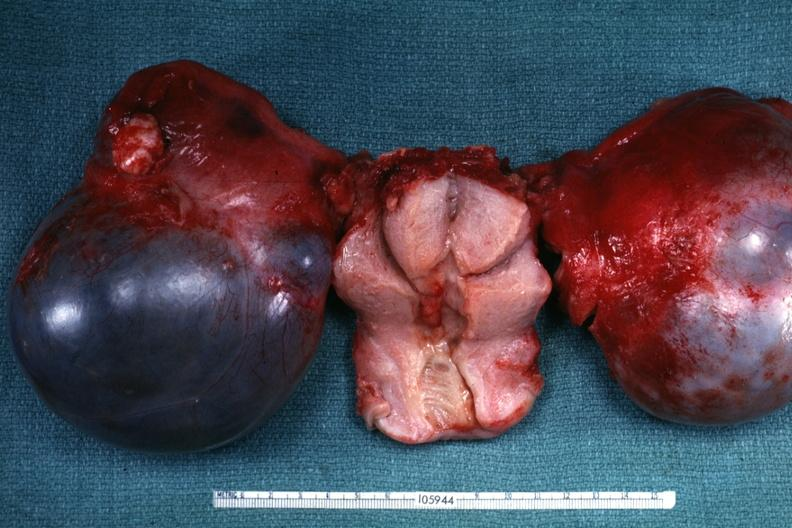what is present?
Answer the question using a single word or phrase. Serous cystadenoma 